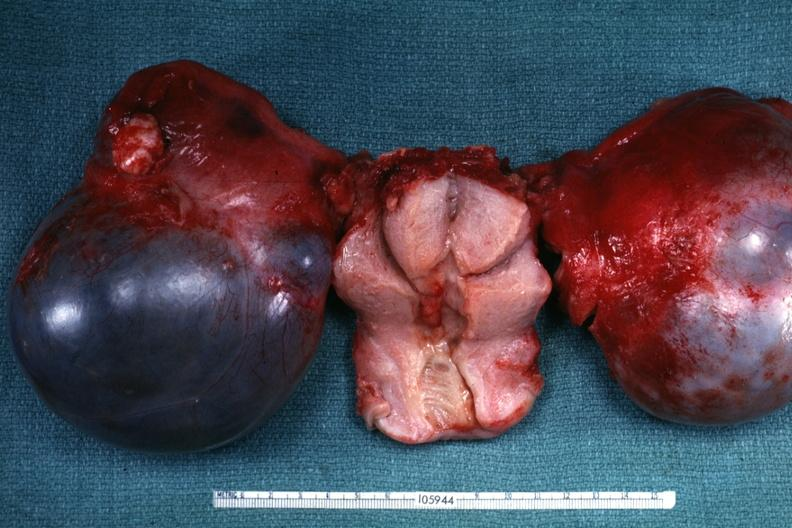what is present?
Answer the question using a single word or phrase. Serous cystadenoma 